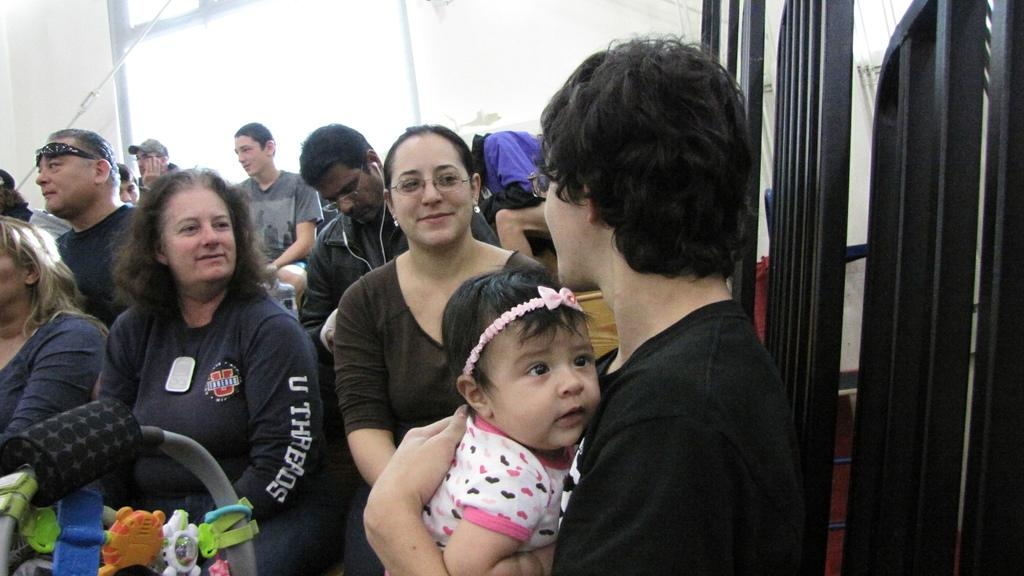Who or what can be seen in the image? There are people in the image. What else is present in the image besides people? There are toys and grilles in the image. Can you describe the objects in the image? There are objects in the image, including toys and grilles. What is visible in the background of the image? There is a wall in the background of the image. What type of pail can be seen in the image? There is no pail present in the image. How does the zephyr affect the people in the image? There is no mention of a zephyr or any weather conditions in the image, so it cannot be determined how it would affect the people. 